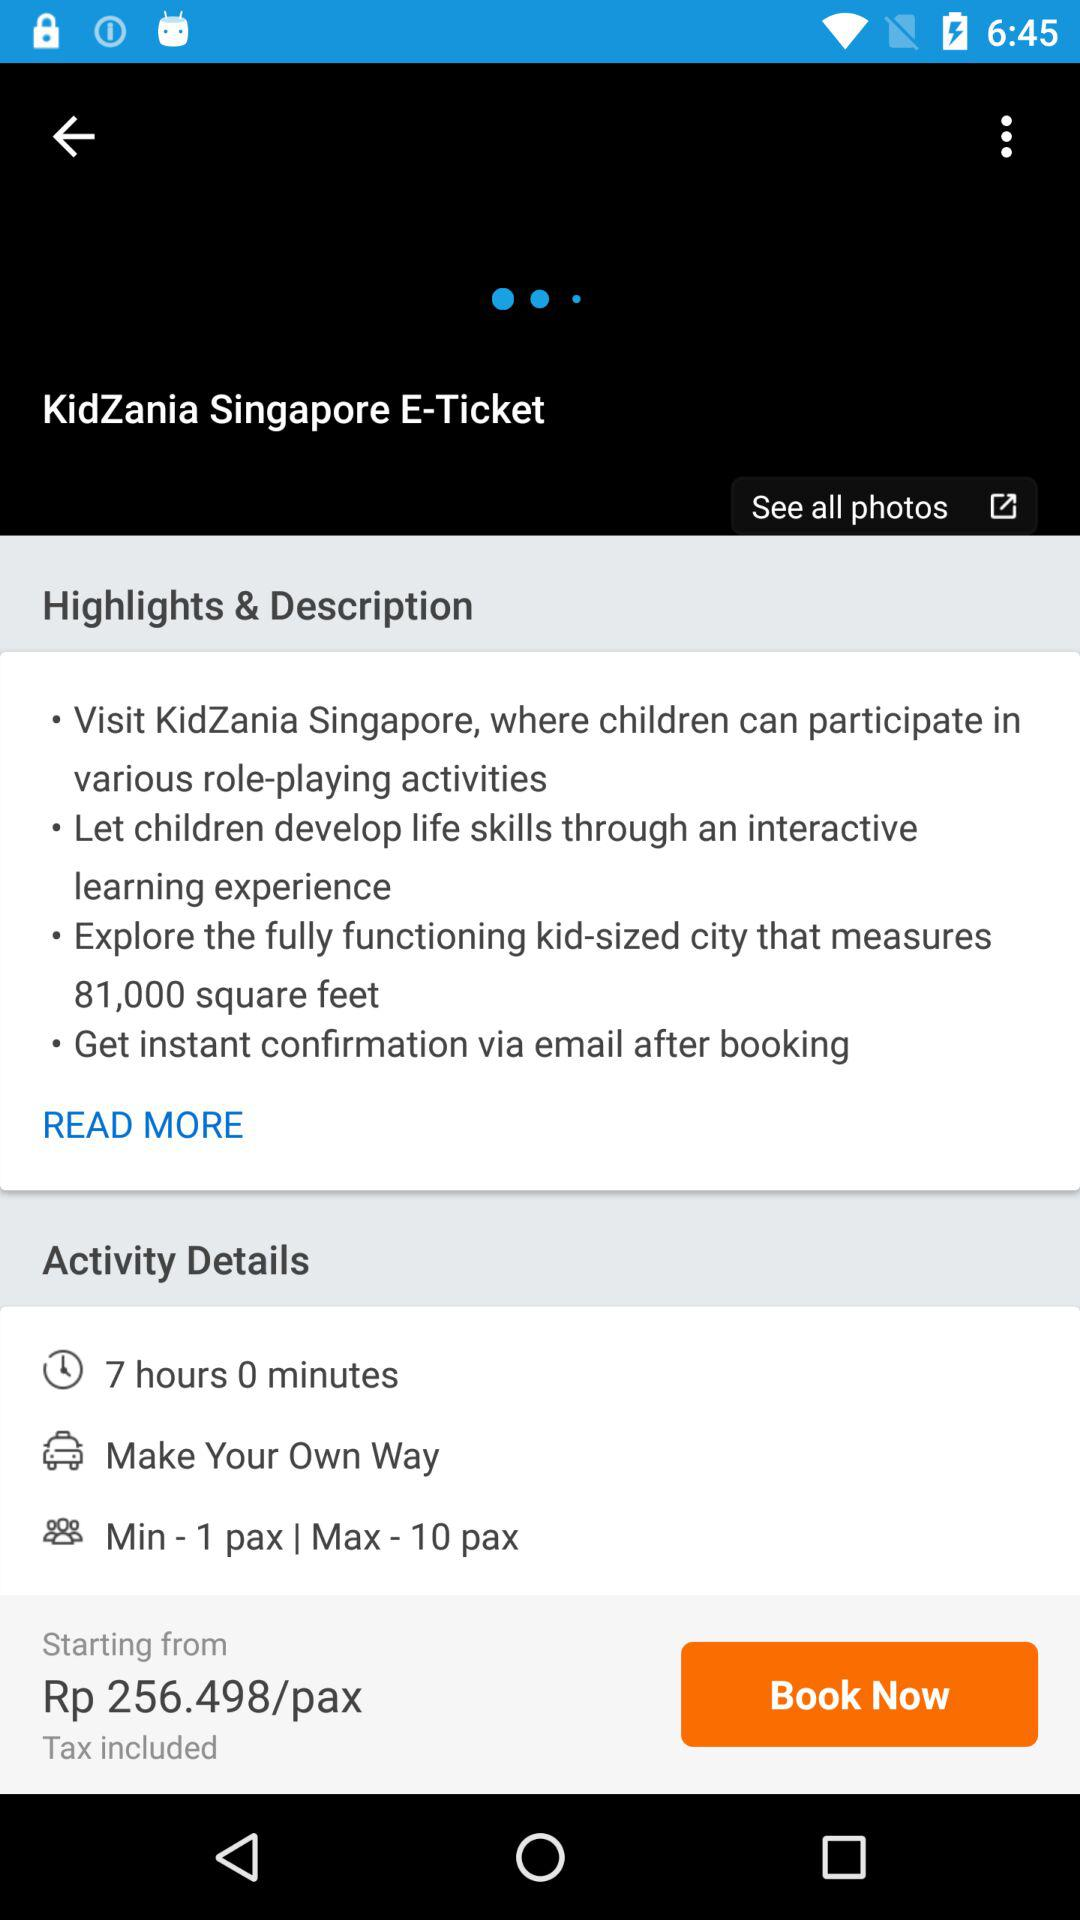What's the activity duration? The activity duration is 7 hours and 0 minutes. 